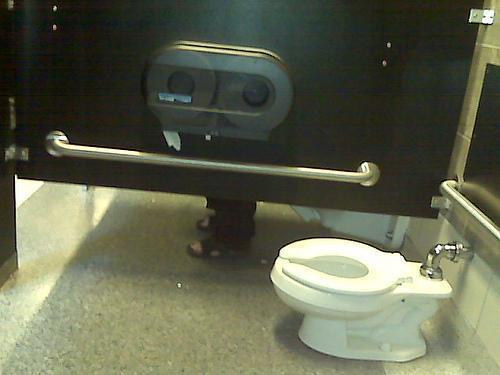How many people are pictured?
Give a very brief answer. 1. How many toilets are there?
Give a very brief answer. 1. How many toilets are pictured?
Give a very brief answer. 1. How many people are pictured here?
Give a very brief answer. 0. How many rolls of toilet paper are in the dispenser?
Give a very brief answer. 2. 